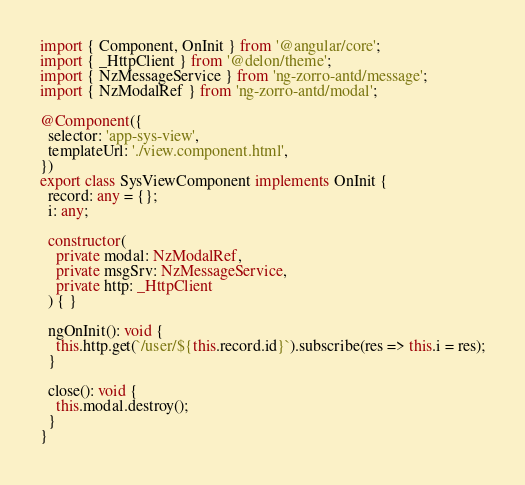<code> <loc_0><loc_0><loc_500><loc_500><_TypeScript_>import { Component, OnInit } from '@angular/core';
import { _HttpClient } from '@delon/theme';
import { NzMessageService } from 'ng-zorro-antd/message';
import { NzModalRef } from 'ng-zorro-antd/modal';

@Component({
  selector: 'app-sys-view',
  templateUrl: './view.component.html',
})
export class SysViewComponent implements OnInit {
  record: any = {};
  i: any;

  constructor(
    private modal: NzModalRef,
    private msgSrv: NzMessageService,
    private http: _HttpClient
  ) { }

  ngOnInit(): void {
    this.http.get(`/user/${this.record.id}`).subscribe(res => this.i = res);
  }

  close(): void {
    this.modal.destroy();
  }
}
</code> 